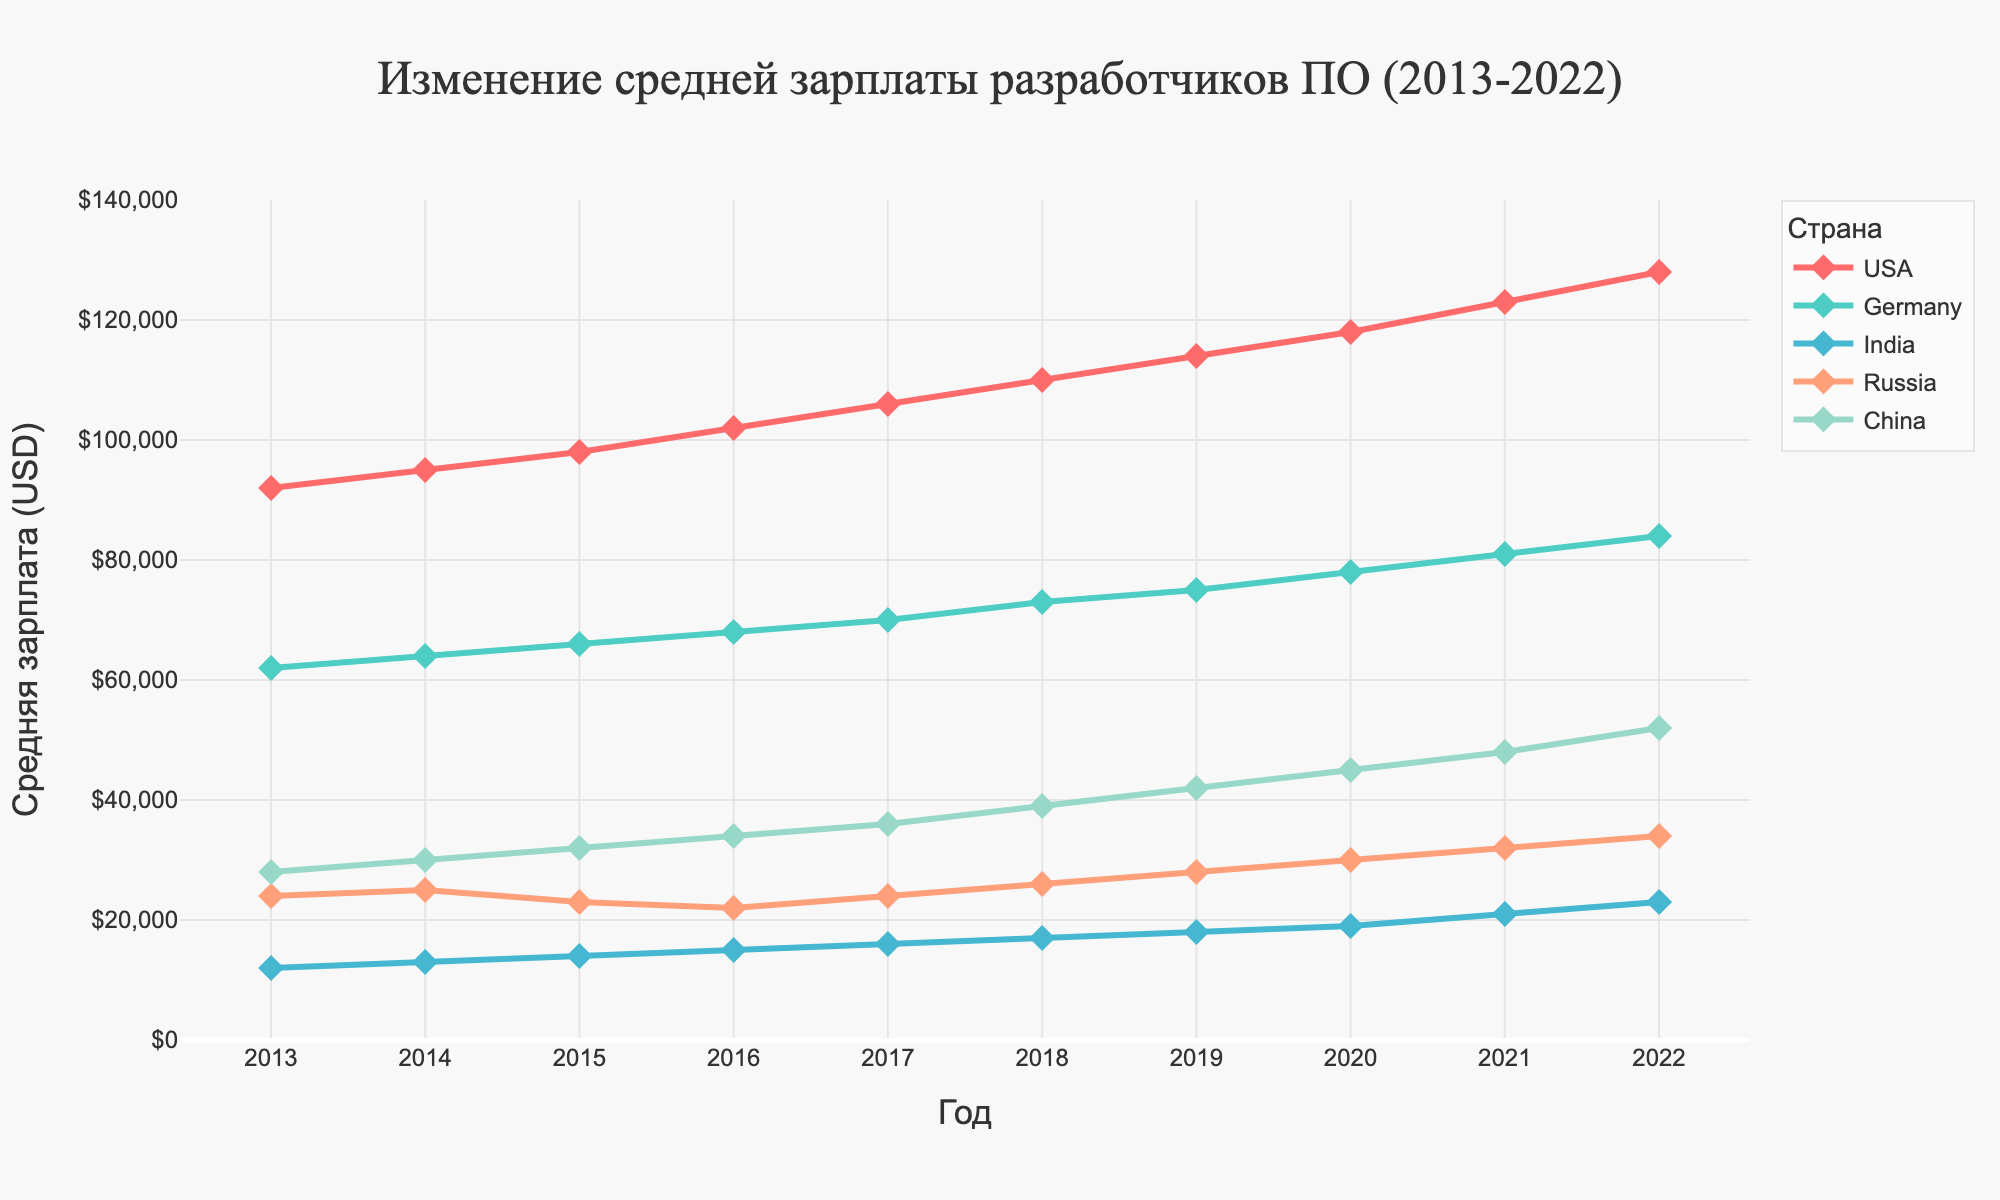What's the average salary of software developers in the USA over the decade? Calculate the average salary by summing up all the annual salaries from 2013 to 2022 and dividing by the number of years. The sum of salaries is 92000 + 95000 + 98000 + 102000 + 106000 + 110000 + 114000 + 118000 + 123000 + 128000 = 1081000. Divide by 10 years to get the average: 1081000 / 10 = 108100.
Answer: 108100 By how much did the average salary of software developers in India increase from 2013 to 2022? Subtract the salary in 2013 from the salary in 2022 for India. The salary in 2022 is 23000, and in 2013 it was 12000. The increase is 23000 - 12000 = 11000.
Answer: 11000 Which country experienced the steepest growth in average salary over the period? Compare the increase in salaries for each country by subtracting the 2013 salary from the 2022 salary. The increases are USA: 36000, Germany: 22000, India: 11000, Russia: 10000, China: 24000. The steepest growth is for the USA.
Answer: USA In which year did software developers in Germany first exceed an average salary of $70000? Look at the salaries for Germany from year to year and find the first year where the salary exceeds 70000. In 2017, the salary was 70000, and it exceeded 70000 in 2018 with 73000.
Answer: 2018 What is the combined total salary for software developers in Russia over the entire period? Add up the annual salaries for Russia from 2013 to 2022. The result is 24000 + 25000 + 23000 + 22000 + 24000 + 26000 + 28000 + 30000 + 32000 + 34000 = 268000.
Answer: 268000 How many countries had an average salary of less than $50000 in 2022? Count the number of countries whose 2022 salary is less than 50000. These countries are India (23000), Russia (34000), and China (52000). Only India and Russia had salaries less than 50000.
Answer: 2 For which countries did the average salary increase every year? Identify which countries' salaries increased each year without any decrease. Checking the data, USA, Germany, India, and China have continuous increases each year. Russia has a decrease between 2015 and 2016.
Answer: USA, Germany, India, China What was the difference in average salary between software developers in the USA and China in 2022? Subtract the average salary of software developers in China from that of the USA in 2022. The USA's salary in 2022 is 128000, and China's salary is 52000. The difference is 128000 - 52000 = 76000.
Answer: 76000 